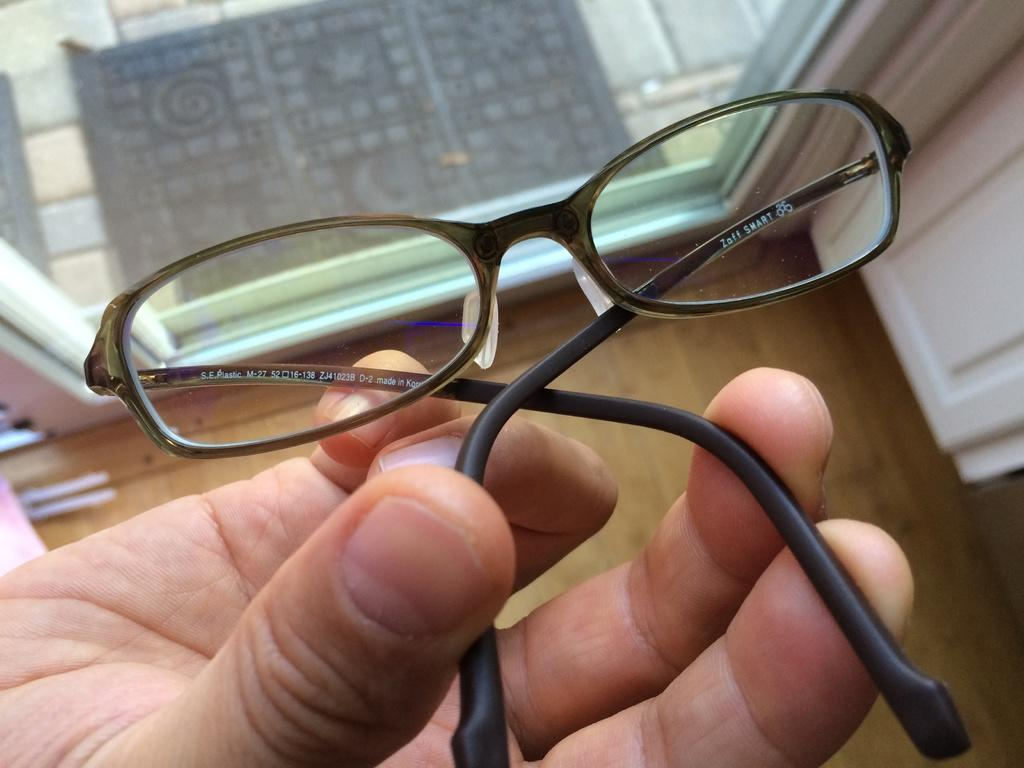What is the person in the image holding in their hand? The person is holding a stick with marshmallows on it. What is the person doing near the fire? The person is standing near the fire, likely to roast the marshmallows on the stick. What can be seen in the background of the image? There are trees in the background of the image. What is being used to fuel the fire? There are logs in the fire. What type of beef is being cooked on the fire in the image? There is no beef present in the image; the person is holding a stick with marshmallows on it. What type of drink is the person holding in their other hand in the image? The image does not show the person holding any drink; they are only holding a stick with marshmallows. 